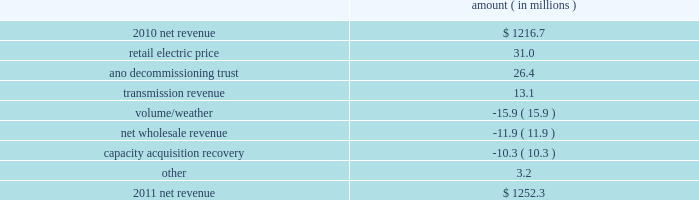Entergy arkansas , inc .
And subsidiaries management 2019s financial discussion and analysis plan to spin off the utility 2019s transmission business see the 201cplan to spin off the utility 2019s transmission business 201d section of entergy corporation and subsidiaries management 2019s financial discussion and analysis for a discussion of this matter , including the planned retirement of debt and preferred securities .
Results of operations net income 2011 compared to 2010 net income decreased $ 7.7 million primarily due to a higher effective income tax rate , lower other income , and higher other operation and maintenance expenses , substantially offset by higher net revenue , lower depreciation and amortization expenses , and lower interest expense .
2010 compared to 2009 net income increased $ 105.7 million primarily due to higher net revenue , a lower effective income tax rate , higher other income , and lower depreciation and amortization expenses , partially offset by higher other operation and maintenance expenses .
Net revenue 2011 compared to 2010 net revenue consists of operating revenues net of : 1 ) fuel , fuel-related expenses , and gas purchased for resale , 2 ) purchased power expenses , and 3 ) other regulatory charges ( credits ) .
Following is an analysis of the change in net revenue comparing 2011 to 2010 .
Amount ( in millions ) .
The retail electric price variance is primarily due to a base rate increase effective july 2010 .
See note 2 to the financial statements for more discussion of the rate case settlement .
The ano decommissioning trust variance is primarily related to the deferral of investment gains from the ano 1 and 2 decommissioning trust in 2010 in accordance with regulatory treatment .
The gains resulted in an increase in 2010 in interest and investment income and a corresponding increase in regulatory charges with no effect on net income. .
What was the ratio of the net income increase in 2010 to the decrease in 2011? 
Computations: (105.7 / 7.7)
Answer: 13.72727. 